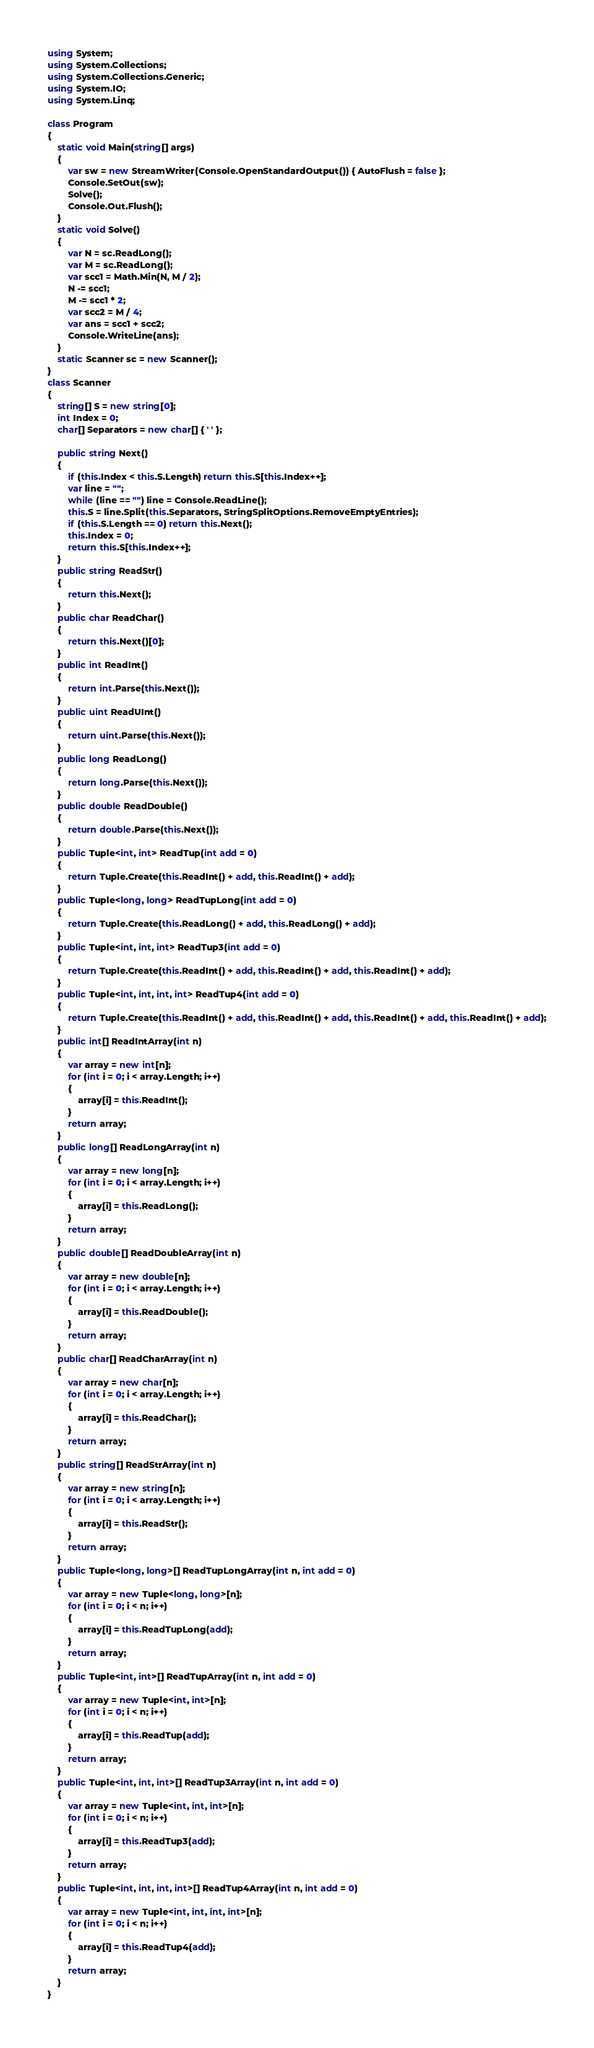<code> <loc_0><loc_0><loc_500><loc_500><_C#_>using System;
using System.Collections;
using System.Collections.Generic;
using System.IO;
using System.Linq;

class Program
{
    static void Main(string[] args)
    {
        var sw = new StreamWriter(Console.OpenStandardOutput()) { AutoFlush = false };
        Console.SetOut(sw);
        Solve();
        Console.Out.Flush();
    }
    static void Solve()
    {
        var N = sc.ReadLong();
        var M = sc.ReadLong();
        var scc1 = Math.Min(N, M / 2);
        N -= scc1;
        M -= scc1 * 2;
        var scc2 = M / 4;
        var ans = scc1 + scc2;
        Console.WriteLine(ans);
    }
    static Scanner sc = new Scanner();
}
class Scanner
{
    string[] S = new string[0];
    int Index = 0;
    char[] Separators = new char[] { ' ' };

    public string Next()
    {
        if (this.Index < this.S.Length) return this.S[this.Index++];
        var line = "";
        while (line == "") line = Console.ReadLine();
        this.S = line.Split(this.Separators, StringSplitOptions.RemoveEmptyEntries);
        if (this.S.Length == 0) return this.Next();
        this.Index = 0;
        return this.S[this.Index++];
    }
    public string ReadStr()
    {
        return this.Next();
    }
    public char ReadChar()
    {
        return this.Next()[0];
    }
    public int ReadInt()
    {
        return int.Parse(this.Next());
    }
    public uint ReadUInt()
    {
        return uint.Parse(this.Next());
    }
    public long ReadLong()
    {
        return long.Parse(this.Next());
    }
    public double ReadDouble()
    {
        return double.Parse(this.Next());
    }
    public Tuple<int, int> ReadTup(int add = 0)
    {
        return Tuple.Create(this.ReadInt() + add, this.ReadInt() + add);
    }
    public Tuple<long, long> ReadTupLong(int add = 0)
    {
        return Tuple.Create(this.ReadLong() + add, this.ReadLong() + add);
    }
    public Tuple<int, int, int> ReadTup3(int add = 0)
    {
        return Tuple.Create(this.ReadInt() + add, this.ReadInt() + add, this.ReadInt() + add);
    }
    public Tuple<int, int, int, int> ReadTup4(int add = 0)
    {
        return Tuple.Create(this.ReadInt() + add, this.ReadInt() + add, this.ReadInt() + add, this.ReadInt() + add);
    }
    public int[] ReadIntArray(int n)
    {
        var array = new int[n];
        for (int i = 0; i < array.Length; i++)
        {
            array[i] = this.ReadInt();
        }
        return array;
    }
    public long[] ReadLongArray(int n)
    {
        var array = new long[n];
        for (int i = 0; i < array.Length; i++)
        {
            array[i] = this.ReadLong();
        }
        return array;
    }
    public double[] ReadDoubleArray(int n)
    {
        var array = new double[n];
        for (int i = 0; i < array.Length; i++)
        {
            array[i] = this.ReadDouble();
        }
        return array;
    }
    public char[] ReadCharArray(int n)
    {
        var array = new char[n];
        for (int i = 0; i < array.Length; i++)
        {
            array[i] = this.ReadChar();
        }
        return array;
    }
    public string[] ReadStrArray(int n)
    {
        var array = new string[n];
        for (int i = 0; i < array.Length; i++)
        {
            array[i] = this.ReadStr();
        }
        return array;
    }
    public Tuple<long, long>[] ReadTupLongArray(int n, int add = 0)
    {
        var array = new Tuple<long, long>[n];
        for (int i = 0; i < n; i++)
        {
            array[i] = this.ReadTupLong(add);
        }
        return array;
    }
    public Tuple<int, int>[] ReadTupArray(int n, int add = 0)
    {
        var array = new Tuple<int, int>[n];
        for (int i = 0; i < n; i++)
        {
            array[i] = this.ReadTup(add);
        }
        return array;
    }
    public Tuple<int, int, int>[] ReadTup3Array(int n, int add = 0)
    {
        var array = new Tuple<int, int, int>[n];
        for (int i = 0; i < n; i++)
        {
            array[i] = this.ReadTup3(add);
        }
        return array;
    }
    public Tuple<int, int, int, int>[] ReadTup4Array(int n, int add = 0)
    {
        var array = new Tuple<int, int, int, int>[n];
        for (int i = 0; i < n; i++)
        {
            array[i] = this.ReadTup4(add);
        }
        return array;
    }
}
</code> 